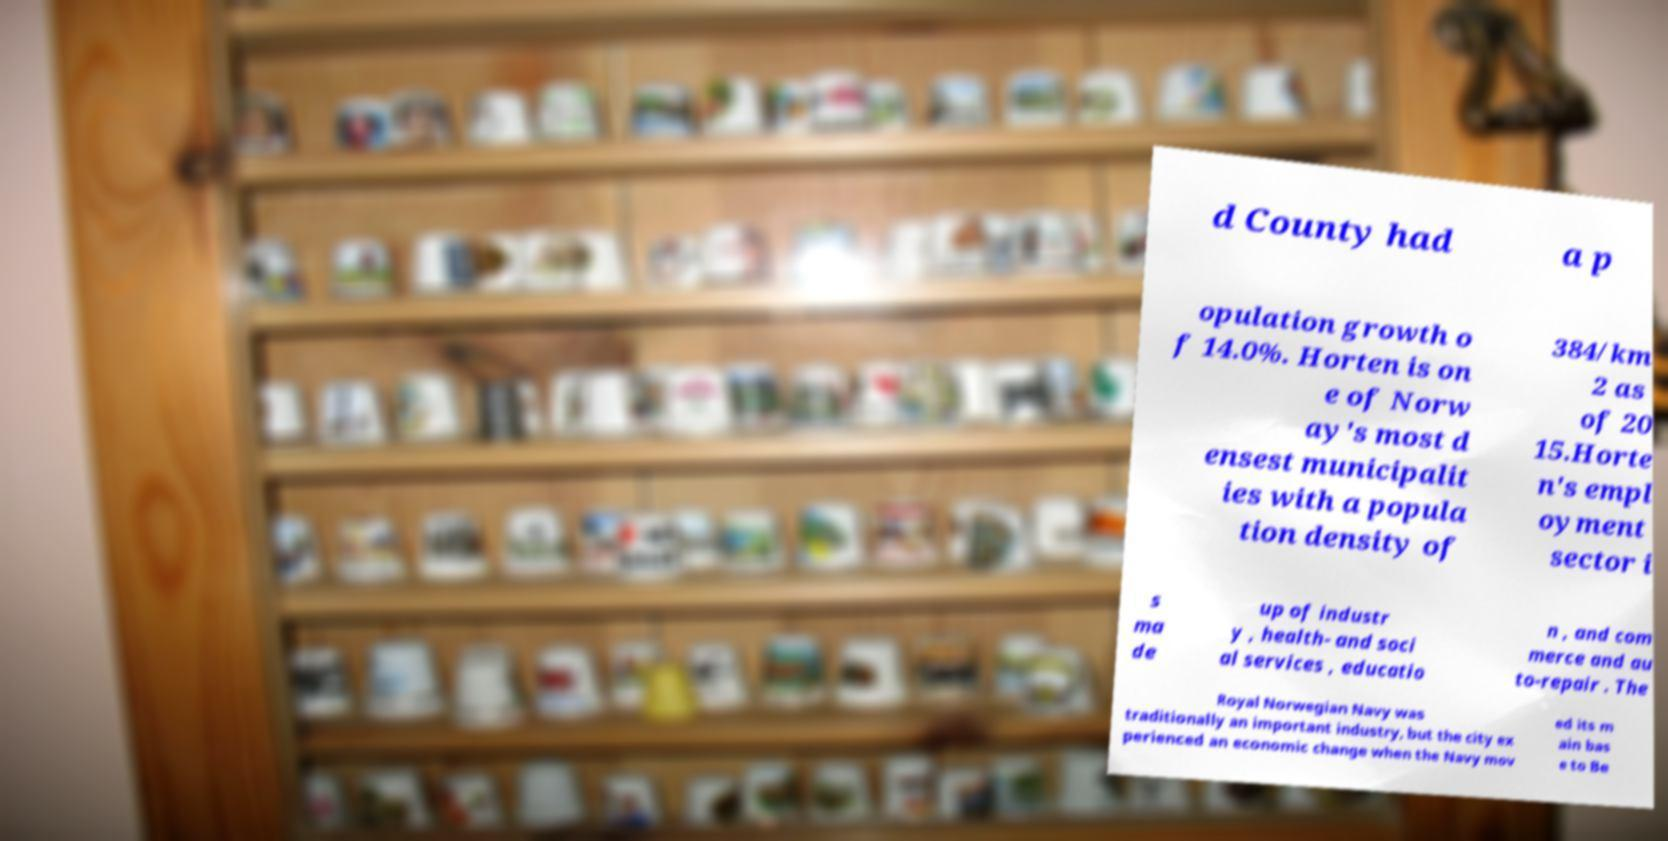Please identify and transcribe the text found in this image. d County had a p opulation growth o f 14.0%. Horten is on e of Norw ay's most d ensest municipalit ies with a popula tion density of 384/km 2 as of 20 15.Horte n's empl oyment sector i s ma de up of industr y , health- and soci al services , educatio n , and com merce and au to-repair . The Royal Norwegian Navy was traditionally an important industry, but the city ex perienced an economic change when the Navy mov ed its m ain bas e to Be 